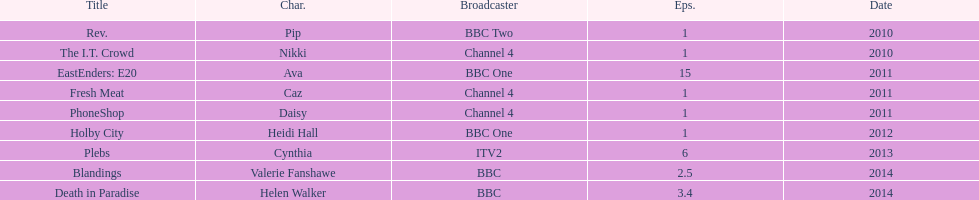How many titles only had one episode? 5. 